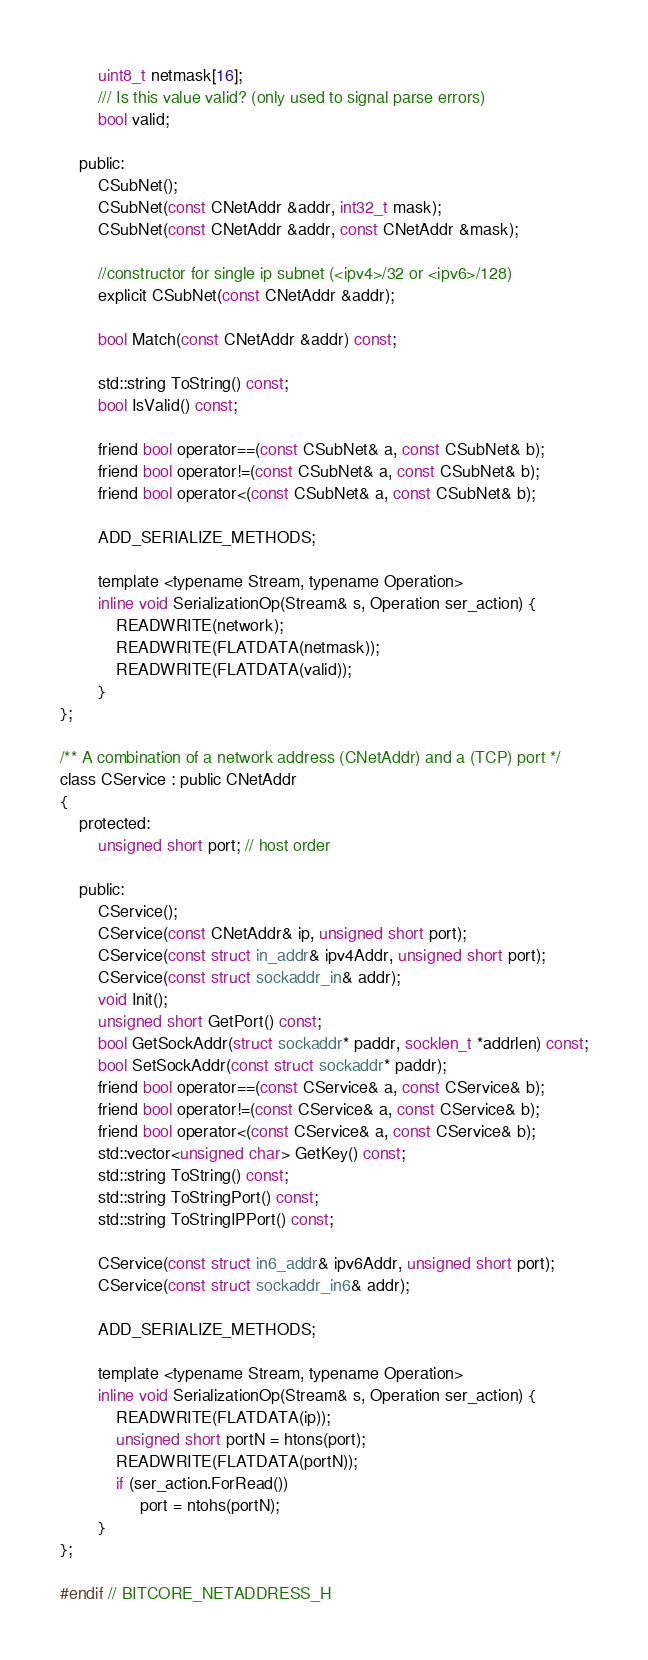Convert code to text. <code><loc_0><loc_0><loc_500><loc_500><_C_>        uint8_t netmask[16];
        /// Is this value valid? (only used to signal parse errors)
        bool valid;

    public:
        CSubNet();
        CSubNet(const CNetAddr &addr, int32_t mask);
        CSubNet(const CNetAddr &addr, const CNetAddr &mask);

        //constructor for single ip subnet (<ipv4>/32 or <ipv6>/128)
        explicit CSubNet(const CNetAddr &addr);

        bool Match(const CNetAddr &addr) const;

        std::string ToString() const;
        bool IsValid() const;

        friend bool operator==(const CSubNet& a, const CSubNet& b);
        friend bool operator!=(const CSubNet& a, const CSubNet& b);
        friend bool operator<(const CSubNet& a, const CSubNet& b);

        ADD_SERIALIZE_METHODS;

        template <typename Stream, typename Operation>
        inline void SerializationOp(Stream& s, Operation ser_action) {
            READWRITE(network);
            READWRITE(FLATDATA(netmask));
            READWRITE(FLATDATA(valid));
        }
};

/** A combination of a network address (CNetAddr) and a (TCP) port */
class CService : public CNetAddr
{
    protected:
        unsigned short port; // host order

    public:
        CService();
        CService(const CNetAddr& ip, unsigned short port);
        CService(const struct in_addr& ipv4Addr, unsigned short port);
        CService(const struct sockaddr_in& addr);
        void Init();
        unsigned short GetPort() const;
        bool GetSockAddr(struct sockaddr* paddr, socklen_t *addrlen) const;
        bool SetSockAddr(const struct sockaddr* paddr);
        friend bool operator==(const CService& a, const CService& b);
        friend bool operator!=(const CService& a, const CService& b);
        friend bool operator<(const CService& a, const CService& b);
        std::vector<unsigned char> GetKey() const;
        std::string ToString() const;
        std::string ToStringPort() const;
        std::string ToStringIPPort() const;

        CService(const struct in6_addr& ipv6Addr, unsigned short port);
        CService(const struct sockaddr_in6& addr);

        ADD_SERIALIZE_METHODS;

        template <typename Stream, typename Operation>
        inline void SerializationOp(Stream& s, Operation ser_action) {
            READWRITE(FLATDATA(ip));
            unsigned short portN = htons(port);
            READWRITE(FLATDATA(portN));
            if (ser_action.ForRead())
                 port = ntohs(portN);
        }
};

#endif // BITCORE_NETADDRESS_H
</code> 